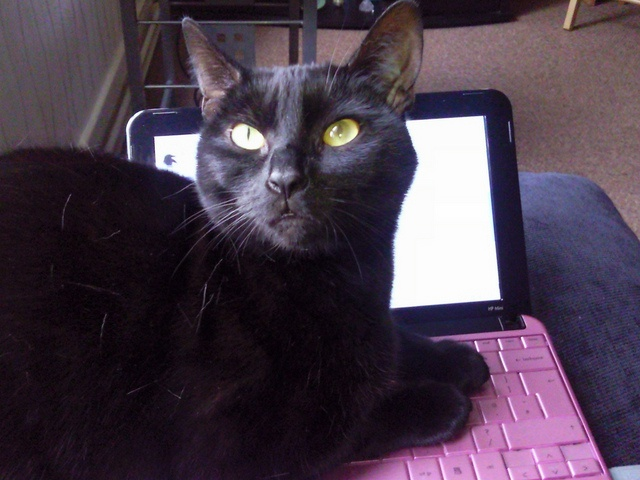Describe the objects in this image and their specific colors. I can see cat in gray, black, and purple tones, laptop in gray, white, black, and violet tones, keyboard in gray, violet, and black tones, and chair in gray and black tones in this image. 